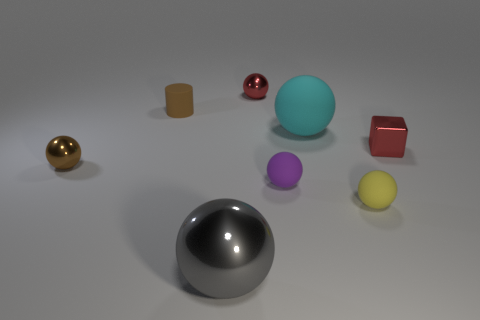Subtract all yellow balls. How many balls are left? 5 Subtract all gray spheres. How many spheres are left? 5 Subtract all yellow balls. Subtract all yellow blocks. How many balls are left? 5 Add 1 yellow spheres. How many objects exist? 9 Subtract all cylinders. How many objects are left? 7 Add 7 green rubber balls. How many green rubber balls exist? 7 Subtract 0 cyan cylinders. How many objects are left? 8 Subtract all tiny cubes. Subtract all cyan spheres. How many objects are left? 6 Add 8 matte cylinders. How many matte cylinders are left? 9 